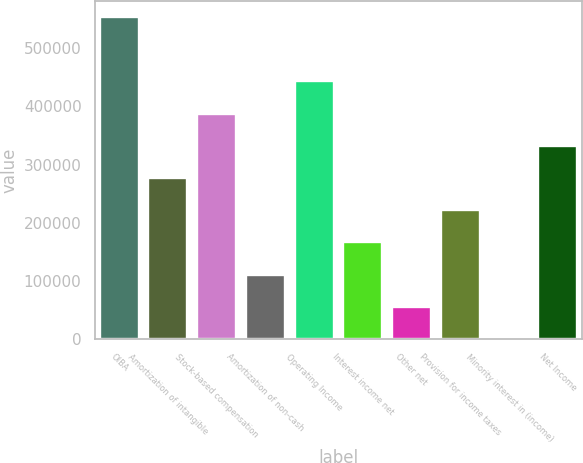Convert chart to OTSL. <chart><loc_0><loc_0><loc_500><loc_500><bar_chart><fcel>OIBA<fcel>Amortization of intangible<fcel>Stock-based compensation<fcel>Amortization of non-cash<fcel>Operating Income<fcel>Interest income net<fcel>Other net<fcel>Provision for income taxes<fcel>Minority interest in (income)<fcel>Net Income<nl><fcel>553692<fcel>276996<fcel>387675<fcel>110979<fcel>443014<fcel>166318<fcel>55640.1<fcel>221657<fcel>301<fcel>332336<nl></chart> 